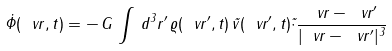Convert formula to latex. <formula><loc_0><loc_0><loc_500><loc_500>\dot { \Phi } ( \ v r , t ) = - \, G \, \int \, d ^ { 3 } r ^ { \prime } \, \varrho ( \ v r ^ { \prime } , t ) \, \vec { v } ( \ v r ^ { \prime } , t ) \vec { \cdot } \frac { \ v r - \ v r ^ { \prime } } { | \ v r - \ v r ^ { \prime } | ^ { 3 } }</formula> 